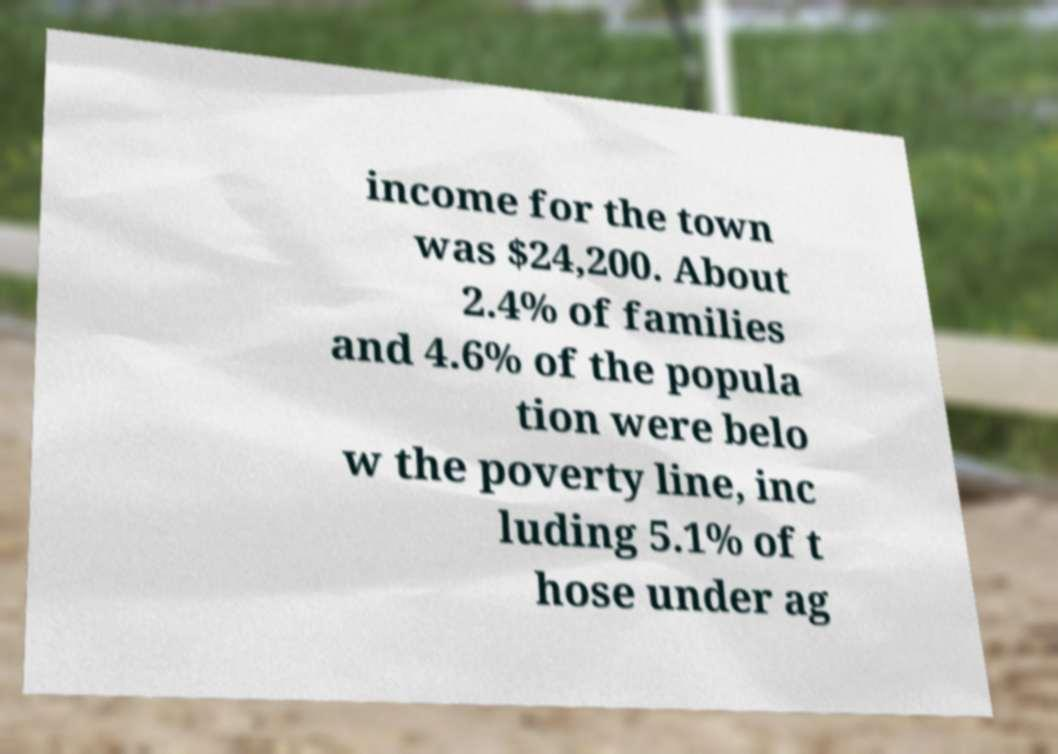There's text embedded in this image that I need extracted. Can you transcribe it verbatim? income for the town was $24,200. About 2.4% of families and 4.6% of the popula tion were belo w the poverty line, inc luding 5.1% of t hose under ag 